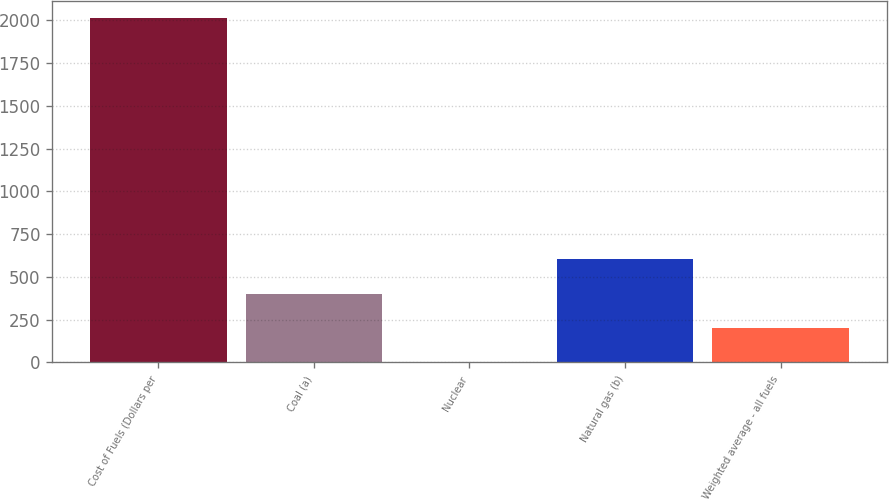Convert chart. <chart><loc_0><loc_0><loc_500><loc_500><bar_chart><fcel>Cost of Fuels (Dollars per<fcel>Coal (a)<fcel>Nuclear<fcel>Natural gas (b)<fcel>Weighted average - all fuels<nl><fcel>2011<fcel>402.81<fcel>0.75<fcel>603.84<fcel>201.78<nl></chart> 